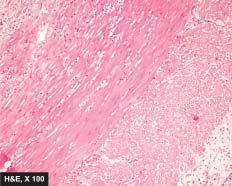re uclear features of malignant cells in malignant melanoma-pleomorphism, anisonucleosis, necrosis of mucosa and periappendicitis?
Answer the question using a single word or phrase. No 